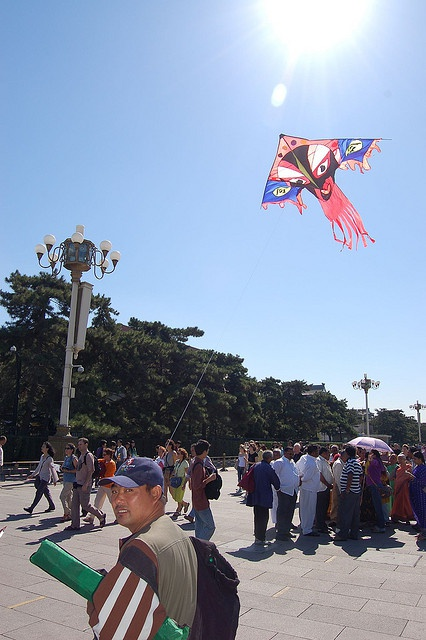Describe the objects in this image and their specific colors. I can see people in darkgray, black, maroon, gray, and lightblue tones, people in darkgray, gray, black, and brown tones, kite in darkgray, white, lightblue, lightpink, and gray tones, backpack in darkgray, black, gray, and lightgray tones, and people in darkgray, black, navy, and gray tones in this image. 